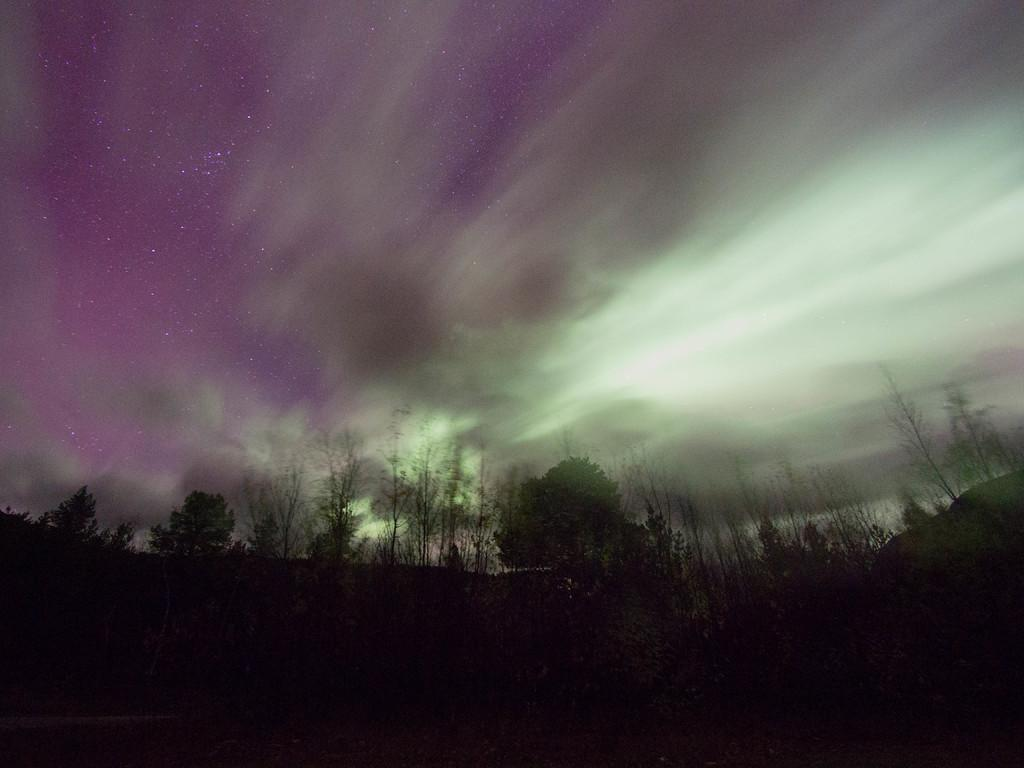What type of vegetation can be seen in the image? There are trees in the image. What part of the natural environment is visible in the image? The sky is visible in the image. What story is being told by the trees in the image? There is no story being told by the trees in the image; they are simply depicted as part of the natural environment. 